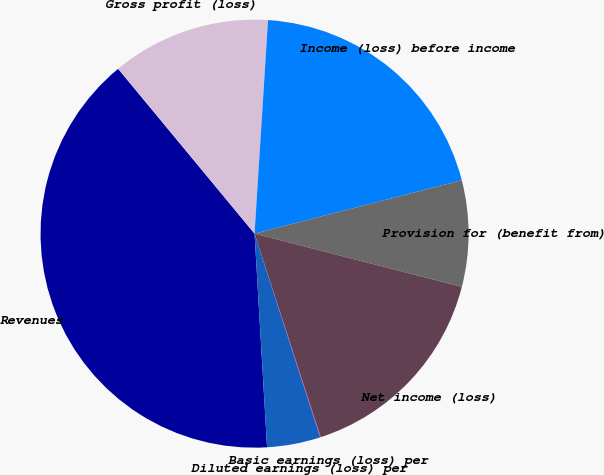<chart> <loc_0><loc_0><loc_500><loc_500><pie_chart><fcel>Revenues<fcel>Gross profit (loss)<fcel>Income (loss) before income<fcel>Provision for (benefit from)<fcel>Net income (loss)<fcel>Basic earnings (loss) per<fcel>Diluted earnings (loss) per<nl><fcel>39.93%<fcel>12.01%<fcel>19.98%<fcel>8.02%<fcel>16.0%<fcel>0.04%<fcel>4.03%<nl></chart> 